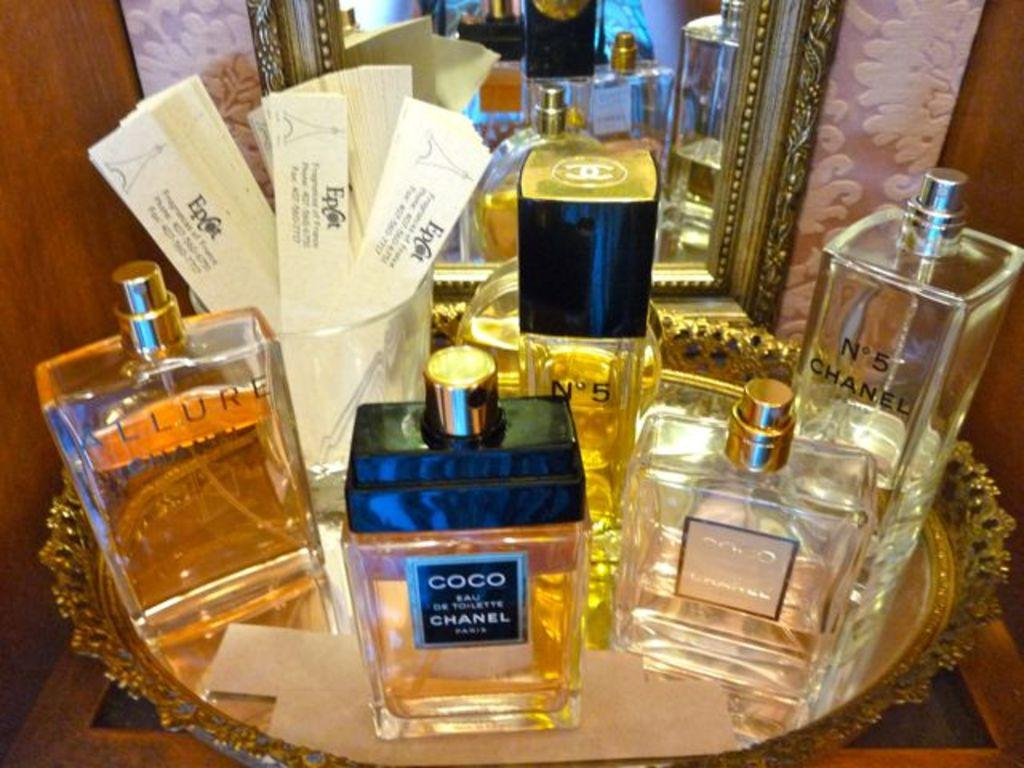<image>
Create a compact narrative representing the image presented. a selection of perfumes, including coco chanel and n0 5 by chanel 